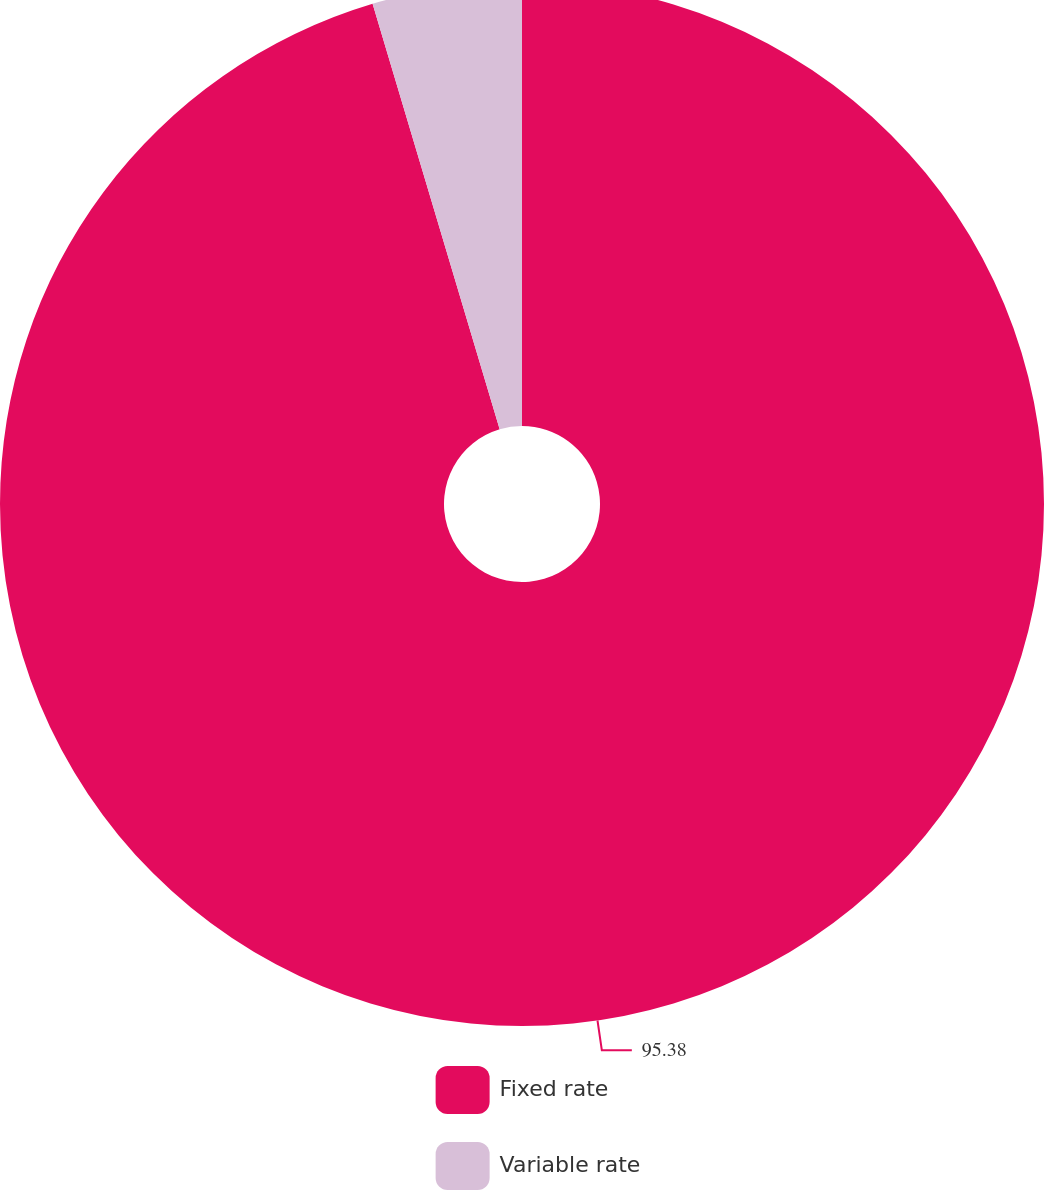Convert chart to OTSL. <chart><loc_0><loc_0><loc_500><loc_500><pie_chart><fcel>Fixed rate<fcel>Variable rate<nl><fcel>95.38%<fcel>4.62%<nl></chart> 